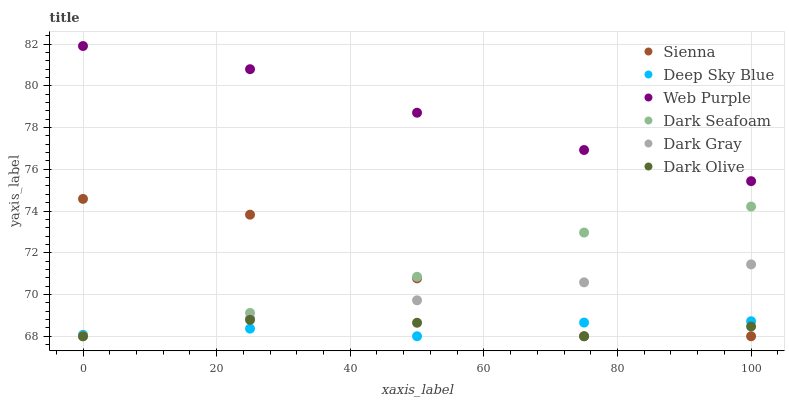Does Deep Sky Blue have the minimum area under the curve?
Answer yes or no. Yes. Does Web Purple have the maximum area under the curve?
Answer yes or no. Yes. Does Dark Olive have the minimum area under the curve?
Answer yes or no. No. Does Dark Olive have the maximum area under the curve?
Answer yes or no. No. Is Dark Gray the smoothest?
Answer yes or no. Yes. Is Sienna the roughest?
Answer yes or no. Yes. Is Dark Olive the smoothest?
Answer yes or no. No. Is Dark Olive the roughest?
Answer yes or no. No. Does Dark Gray have the lowest value?
Answer yes or no. Yes. Does Web Purple have the lowest value?
Answer yes or no. No. Does Web Purple have the highest value?
Answer yes or no. Yes. Does Dark Olive have the highest value?
Answer yes or no. No. Is Deep Sky Blue less than Web Purple?
Answer yes or no. Yes. Is Web Purple greater than Dark Seafoam?
Answer yes or no. Yes. Does Dark Olive intersect Sienna?
Answer yes or no. Yes. Is Dark Olive less than Sienna?
Answer yes or no. No. Is Dark Olive greater than Sienna?
Answer yes or no. No. Does Deep Sky Blue intersect Web Purple?
Answer yes or no. No. 